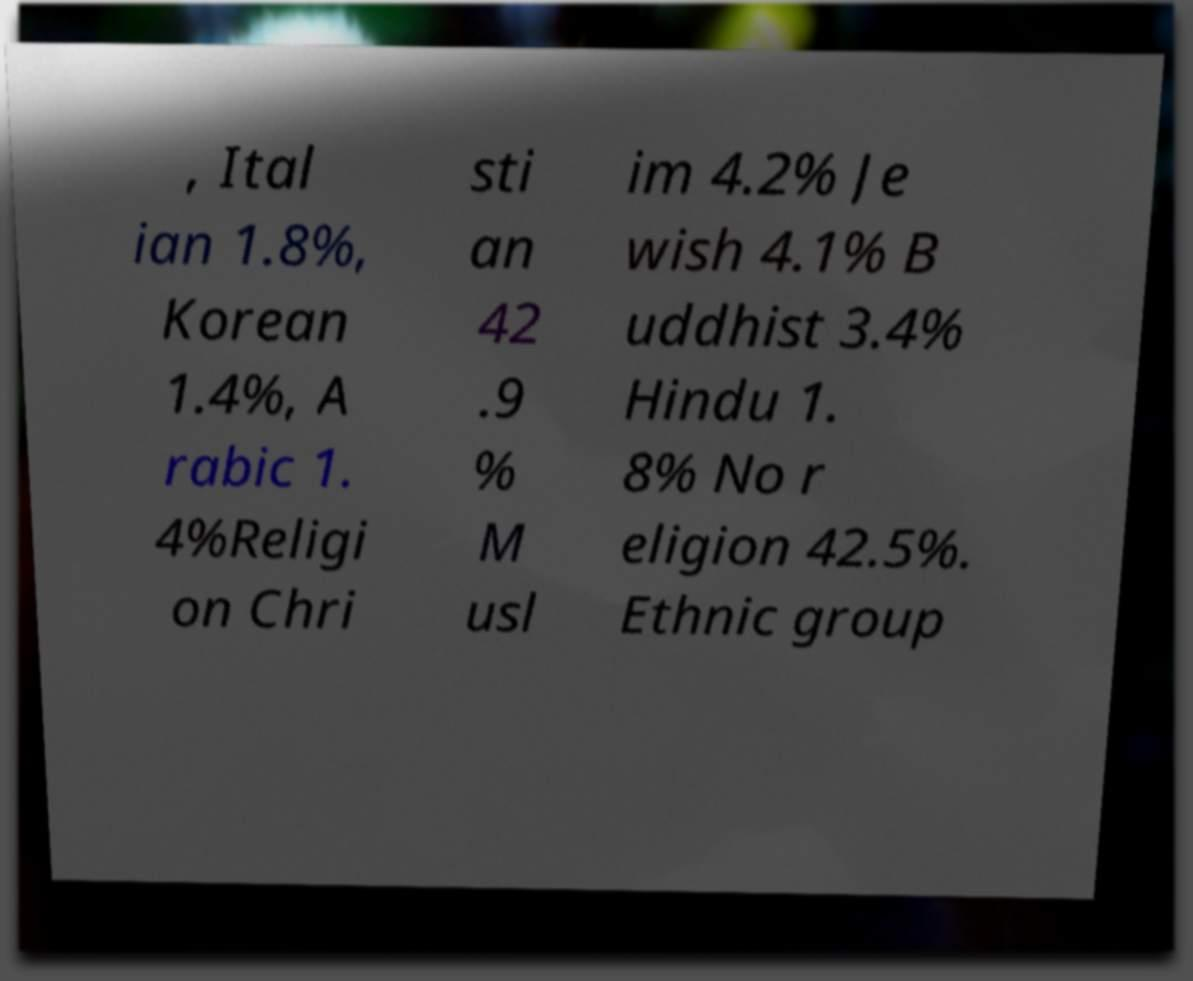Can you accurately transcribe the text from the provided image for me? , Ital ian 1.8%, Korean 1.4%, A rabic 1. 4%Religi on Chri sti an 42 .9 % M usl im 4.2% Je wish 4.1% B uddhist 3.4% Hindu 1. 8% No r eligion 42.5%. Ethnic group 